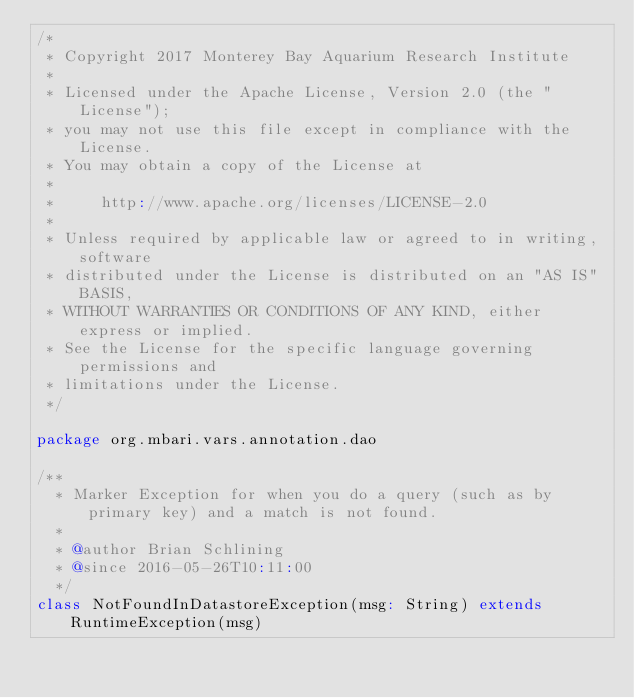Convert code to text. <code><loc_0><loc_0><loc_500><loc_500><_Scala_>/*
 * Copyright 2017 Monterey Bay Aquarium Research Institute
 *
 * Licensed under the Apache License, Version 2.0 (the "License");
 * you may not use this file except in compliance with the License.
 * You may obtain a copy of the License at
 *
 *     http://www.apache.org/licenses/LICENSE-2.0
 *
 * Unless required by applicable law or agreed to in writing, software
 * distributed under the License is distributed on an "AS IS" BASIS,
 * WITHOUT WARRANTIES OR CONDITIONS OF ANY KIND, either express or implied.
 * See the License for the specific language governing permissions and
 * limitations under the License.
 */

package org.mbari.vars.annotation.dao

/**
  * Marker Exception for when you do a query (such as by primary key) and a match is not found.
  *
  * @author Brian Schlining
  * @since 2016-05-26T10:11:00
  */
class NotFoundInDatastoreException(msg: String) extends RuntimeException(msg)
</code> 